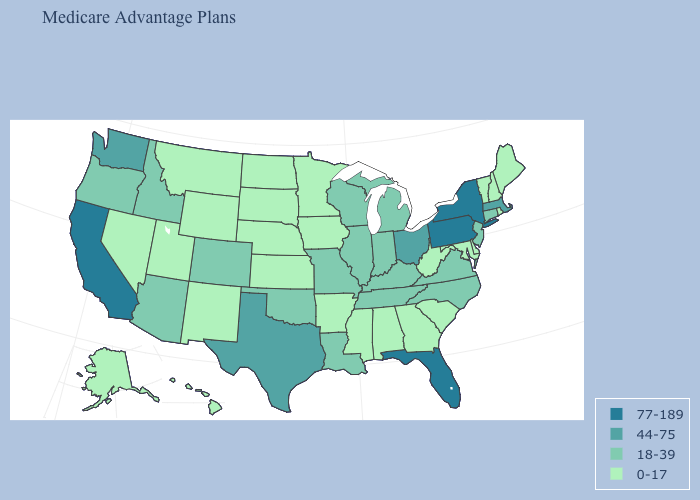Which states have the highest value in the USA?
Keep it brief. California, Florida, New York, Pennsylvania. What is the value of New Mexico?
Short answer required. 0-17. Among the states that border Arkansas , which have the lowest value?
Quick response, please. Mississippi. What is the highest value in the USA?
Answer briefly. 77-189. Name the states that have a value in the range 0-17?
Write a very short answer. Alaska, Alabama, Arkansas, Delaware, Georgia, Hawaii, Iowa, Kansas, Maryland, Maine, Minnesota, Mississippi, Montana, North Dakota, Nebraska, New Hampshire, New Mexico, Nevada, Rhode Island, South Carolina, South Dakota, Utah, Vermont, West Virginia, Wyoming. Which states have the lowest value in the MidWest?
Quick response, please. Iowa, Kansas, Minnesota, North Dakota, Nebraska, South Dakota. Does Arkansas have the highest value in the USA?
Write a very short answer. No. Which states hav the highest value in the MidWest?
Answer briefly. Ohio. Does Louisiana have the highest value in the South?
Keep it brief. No. Name the states that have a value in the range 77-189?
Short answer required. California, Florida, New York, Pennsylvania. Which states hav the highest value in the Northeast?
Short answer required. New York, Pennsylvania. What is the value of Alaska?
Write a very short answer. 0-17. Which states have the lowest value in the West?
Write a very short answer. Alaska, Hawaii, Montana, New Mexico, Nevada, Utah, Wyoming. Does Pennsylvania have the same value as New York?
Write a very short answer. Yes. Name the states that have a value in the range 77-189?
Give a very brief answer. California, Florida, New York, Pennsylvania. 